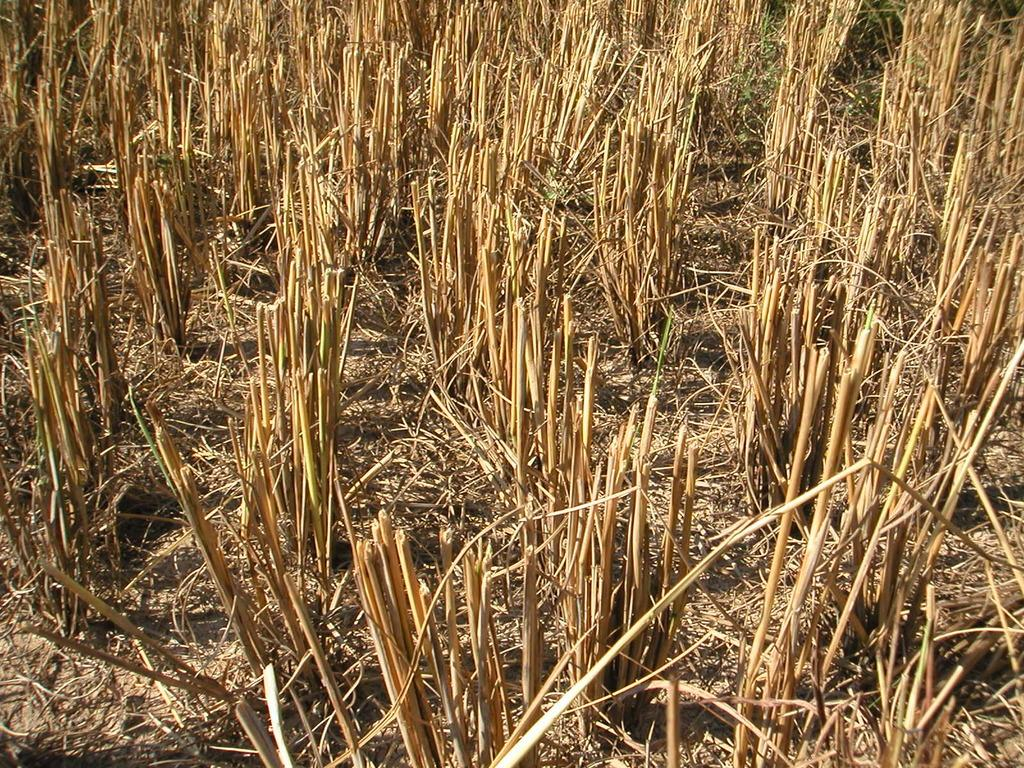What type of vegetation can be seen in the image? There is grass in the image. Can you describe the texture or appearance of the grass? The grass appears to be green and may be growing or covering the ground. Is there any other natural element visible in the image besides the grass? The provided facts do not mention any other natural elements in the image. How many arches can be seen in the image? There are no arches present in the image; it only features grass. 